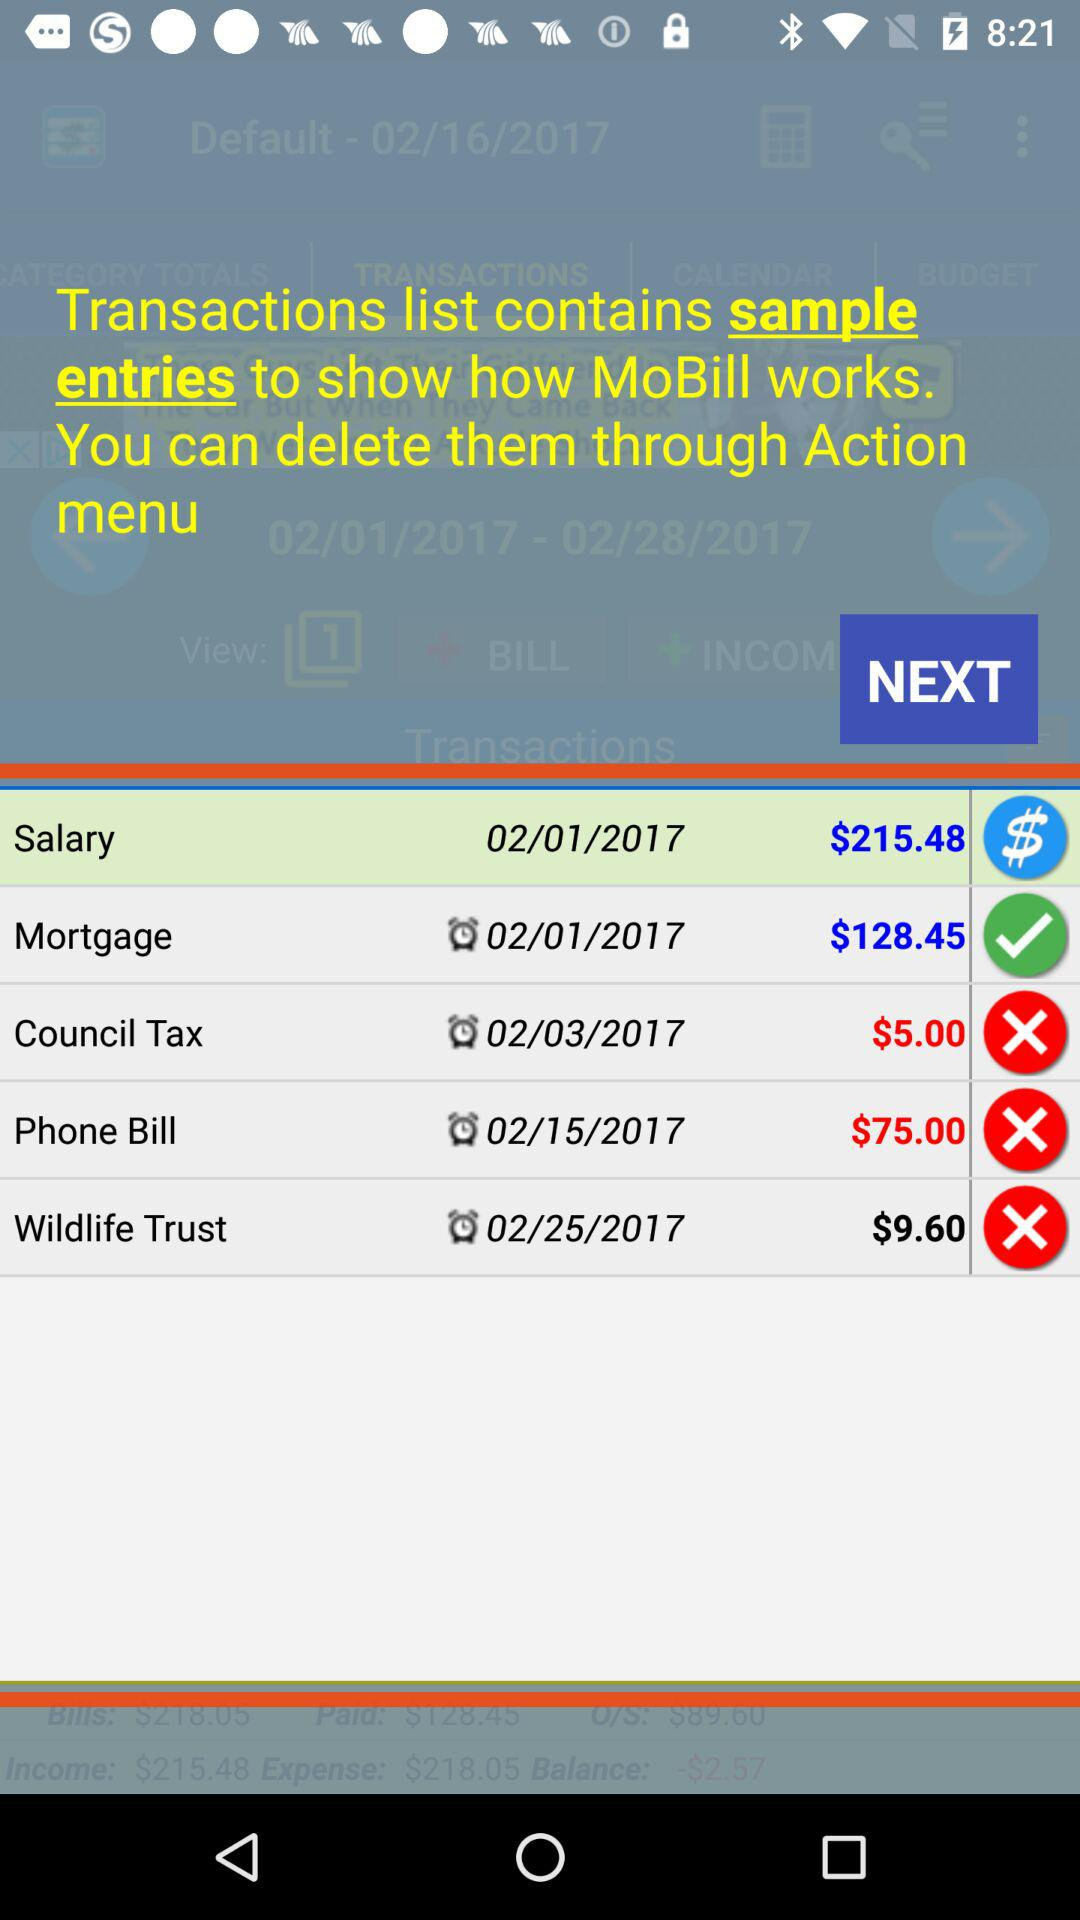What is the amount of the salary? The amount of the salary is $215.48. 